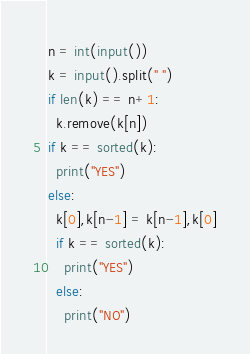<code> <loc_0><loc_0><loc_500><loc_500><_Python_>n = int(input())
k = input().split(" ")
if len(k) == n+1:
  k.remove(k[n])
if k == sorted(k):
  print("YES")
else:
  k[0],k[n-1] = k[n-1],k[0]
  if k == sorted(k):
    print("YES")
  else:
    print("NO")</code> 